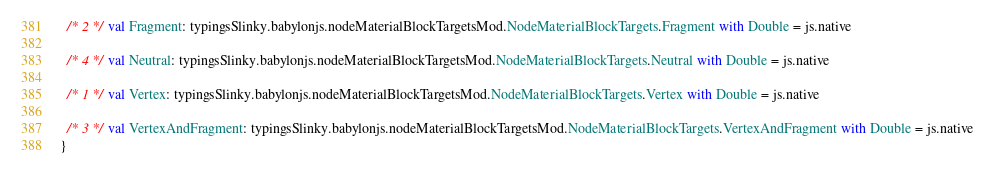Convert code to text. <code><loc_0><loc_0><loc_500><loc_500><_Scala_>  /* 2 */ val Fragment: typingsSlinky.babylonjs.nodeMaterialBlockTargetsMod.NodeMaterialBlockTargets.Fragment with Double = js.native
  
  /* 4 */ val Neutral: typingsSlinky.babylonjs.nodeMaterialBlockTargetsMod.NodeMaterialBlockTargets.Neutral with Double = js.native
  
  /* 1 */ val Vertex: typingsSlinky.babylonjs.nodeMaterialBlockTargetsMod.NodeMaterialBlockTargets.Vertex with Double = js.native
  
  /* 3 */ val VertexAndFragment: typingsSlinky.babylonjs.nodeMaterialBlockTargetsMod.NodeMaterialBlockTargets.VertexAndFragment with Double = js.native
}
</code> 